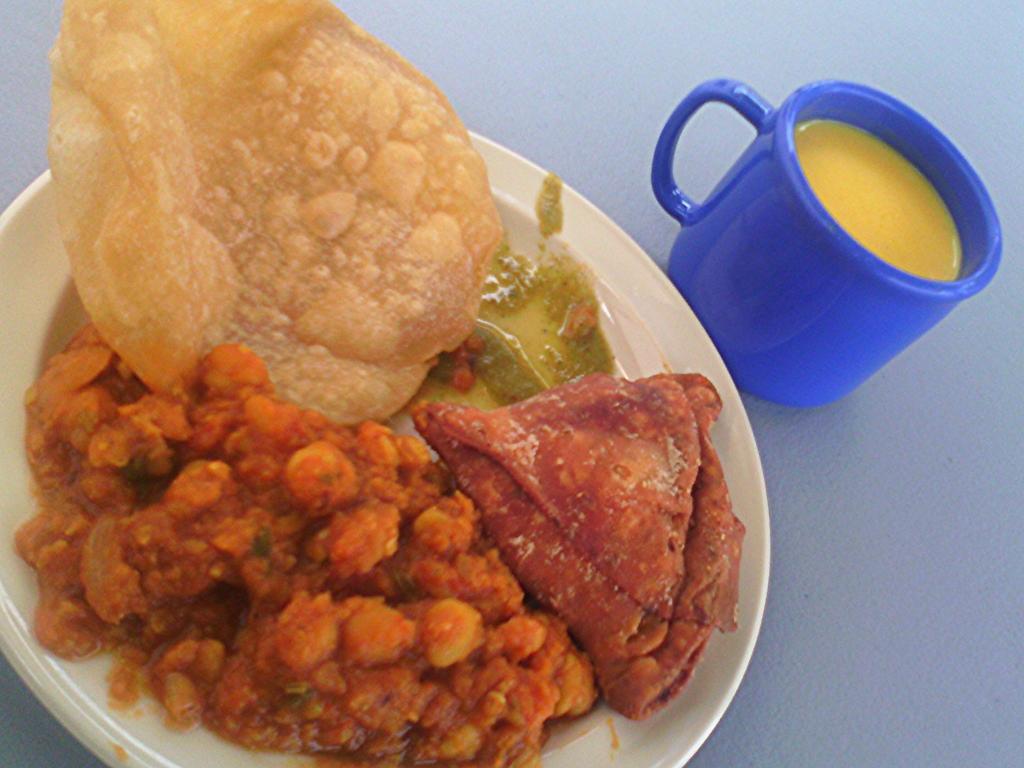In one or two sentences, can you explain what this image depicts? In this picture we can see a plate which contains food items and a cup which contains liquid on the surface. 